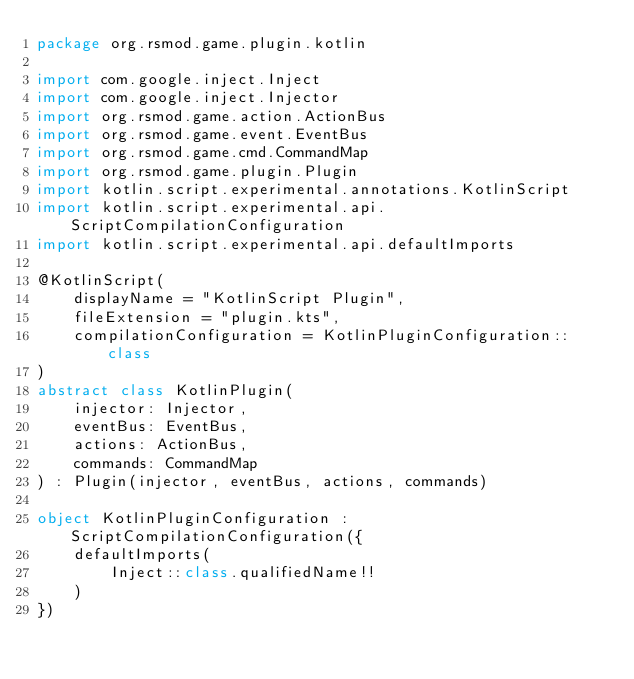Convert code to text. <code><loc_0><loc_0><loc_500><loc_500><_Kotlin_>package org.rsmod.game.plugin.kotlin

import com.google.inject.Inject
import com.google.inject.Injector
import org.rsmod.game.action.ActionBus
import org.rsmod.game.event.EventBus
import org.rsmod.game.cmd.CommandMap
import org.rsmod.game.plugin.Plugin
import kotlin.script.experimental.annotations.KotlinScript
import kotlin.script.experimental.api.ScriptCompilationConfiguration
import kotlin.script.experimental.api.defaultImports

@KotlinScript(
    displayName = "KotlinScript Plugin",
    fileExtension = "plugin.kts",
    compilationConfiguration = KotlinPluginConfiguration::class
)
abstract class KotlinPlugin(
    injector: Injector,
    eventBus: EventBus,
    actions: ActionBus,
    commands: CommandMap
) : Plugin(injector, eventBus, actions, commands)

object KotlinPluginConfiguration : ScriptCompilationConfiguration({
    defaultImports(
        Inject::class.qualifiedName!!
    )
})
</code> 